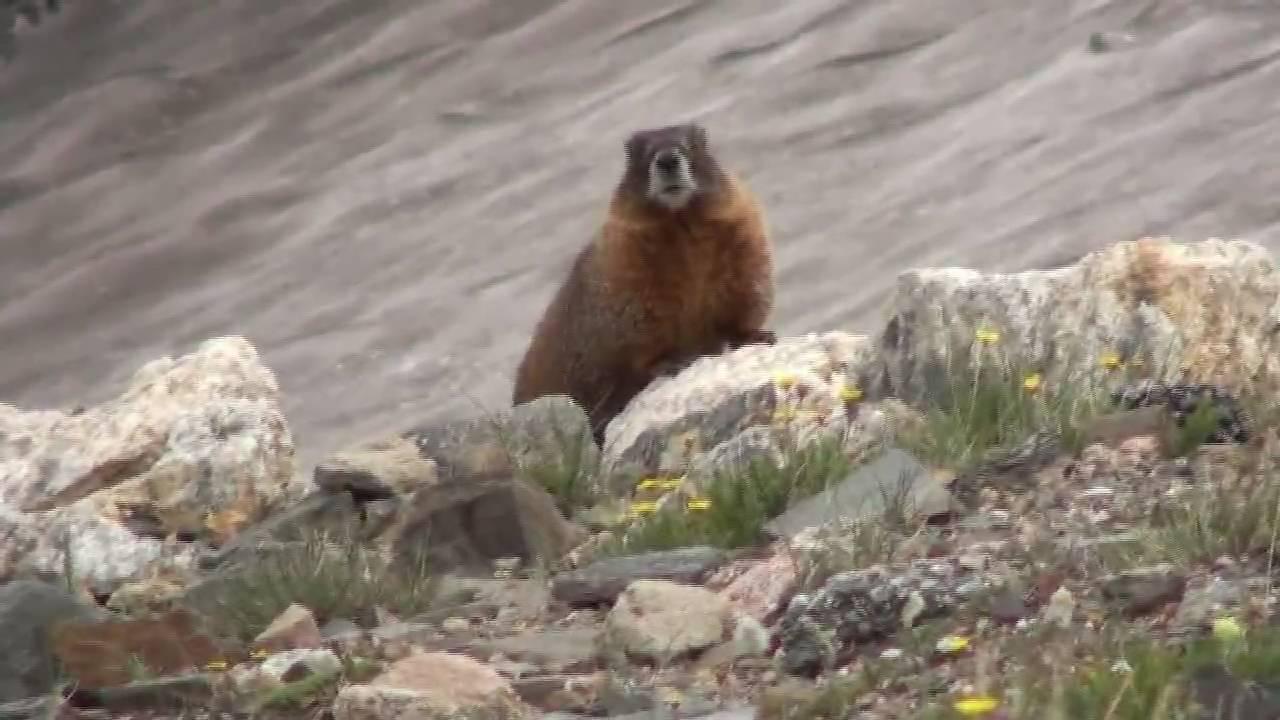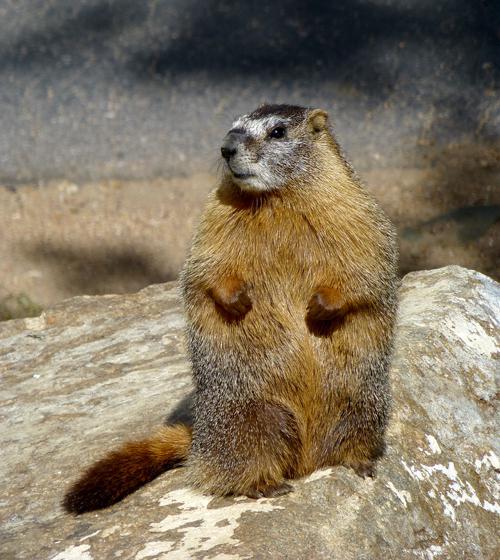The first image is the image on the left, the second image is the image on the right. Analyze the images presented: Is the assertion "A type of rodent is sitting on a rock with both front legs up in the air." valid? Answer yes or no. Yes. The first image is the image on the left, the second image is the image on the right. Assess this claim about the two images: "An image shows a marmot posed on all fours on a rock, and the image contains only one rock.". Correct or not? Answer yes or no. No. 